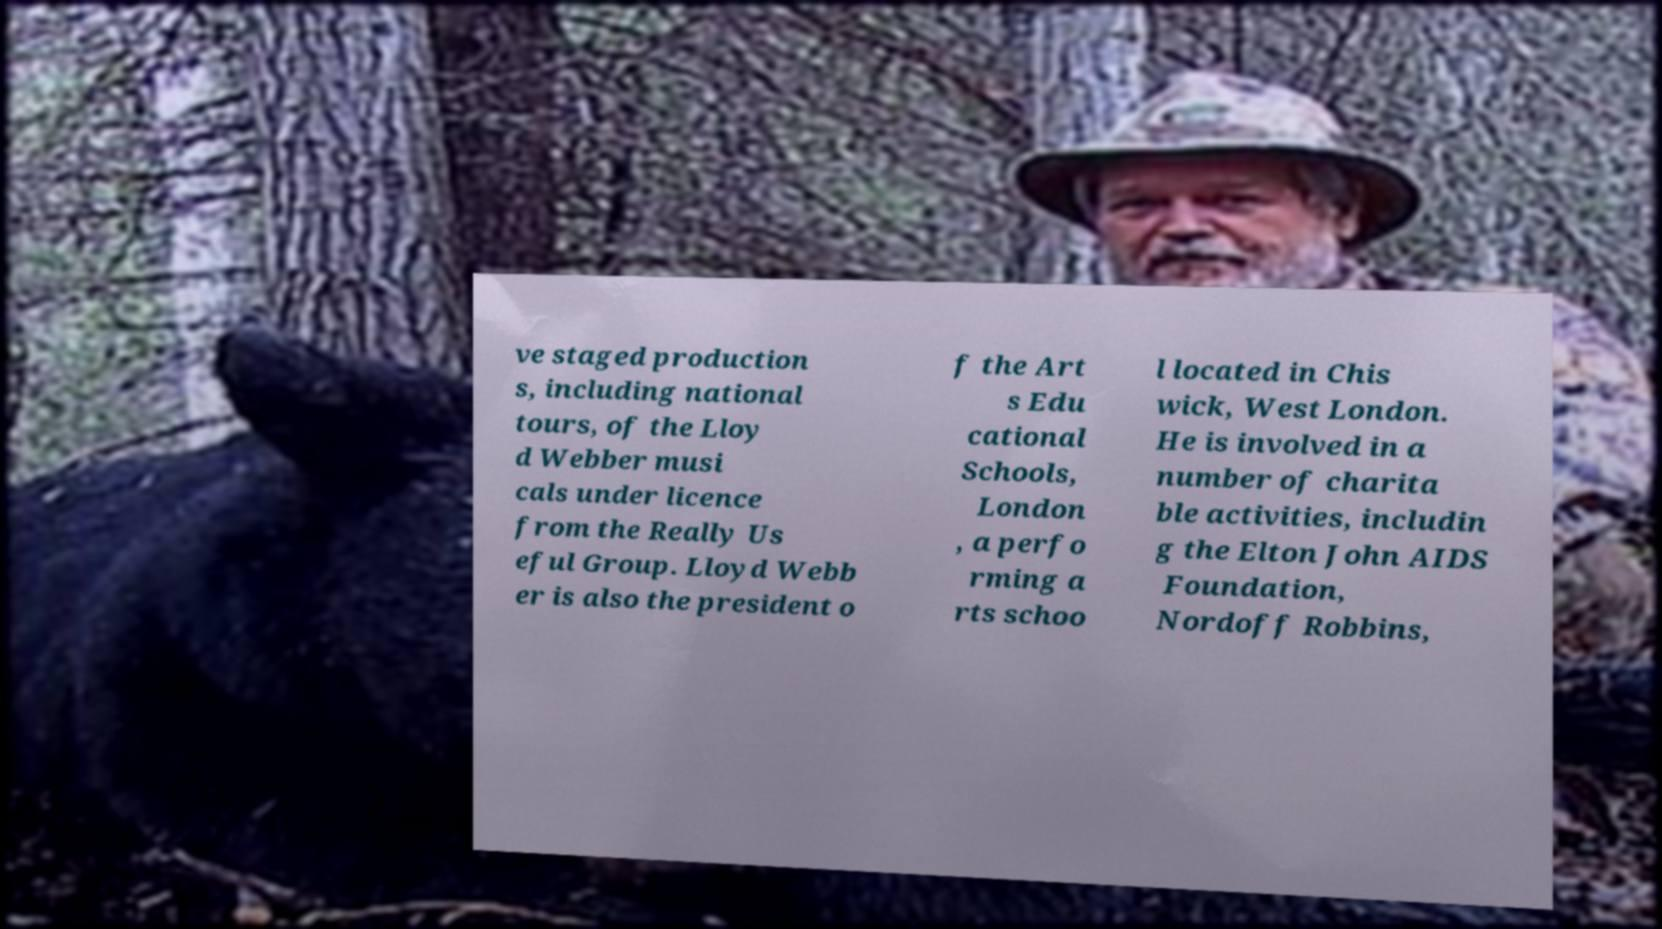There's text embedded in this image that I need extracted. Can you transcribe it verbatim? ve staged production s, including national tours, of the Lloy d Webber musi cals under licence from the Really Us eful Group. Lloyd Webb er is also the president o f the Art s Edu cational Schools, London , a perfo rming a rts schoo l located in Chis wick, West London. He is involved in a number of charita ble activities, includin g the Elton John AIDS Foundation, Nordoff Robbins, 